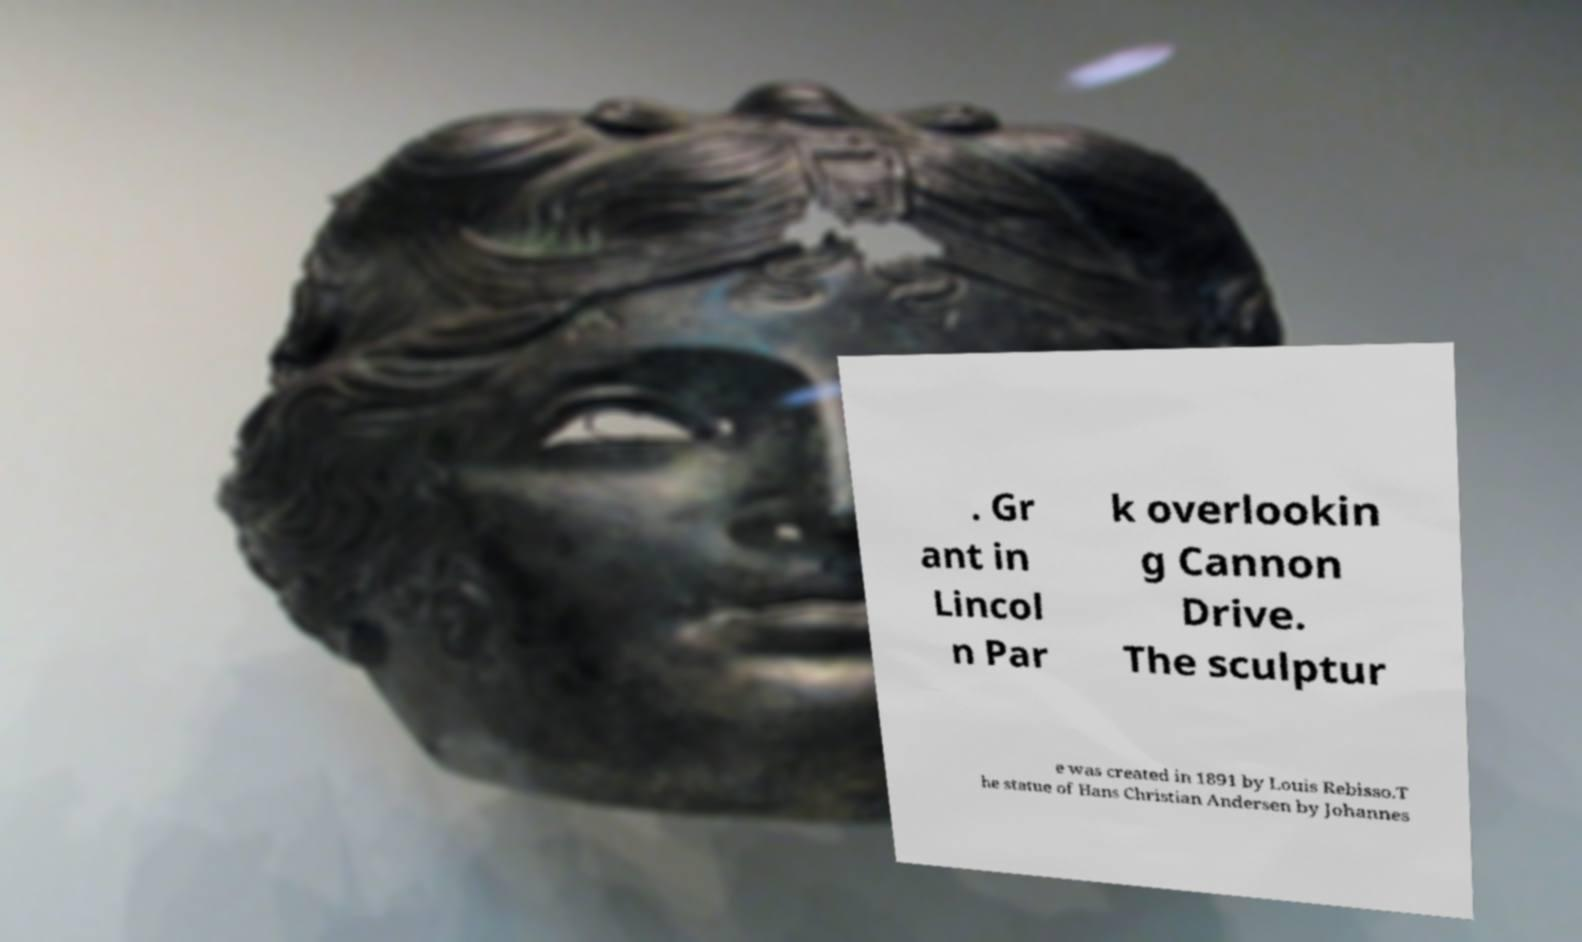Could you extract and type out the text from this image? . Gr ant in Lincol n Par k overlookin g Cannon Drive. The sculptur e was created in 1891 by Louis Rebisso.T he statue of Hans Christian Andersen by Johannes 